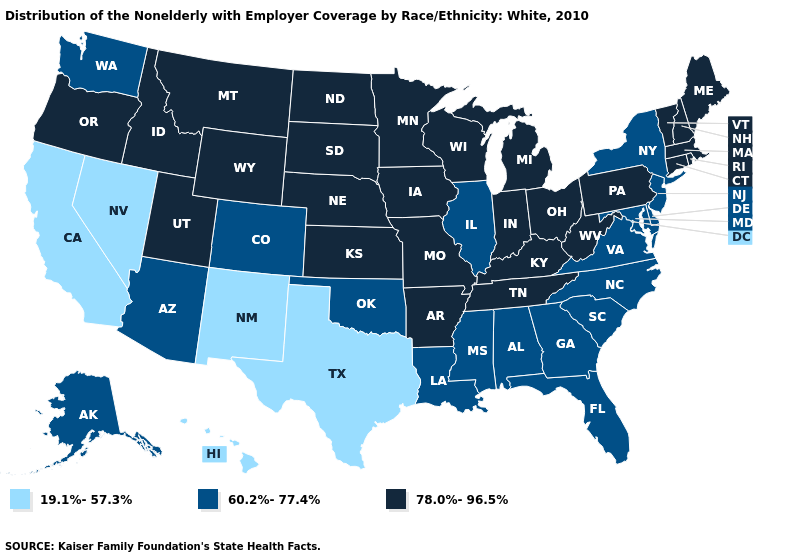Name the states that have a value in the range 78.0%-96.5%?
Short answer required. Arkansas, Connecticut, Idaho, Indiana, Iowa, Kansas, Kentucky, Maine, Massachusetts, Michigan, Minnesota, Missouri, Montana, Nebraska, New Hampshire, North Dakota, Ohio, Oregon, Pennsylvania, Rhode Island, South Dakota, Tennessee, Utah, Vermont, West Virginia, Wisconsin, Wyoming. Name the states that have a value in the range 78.0%-96.5%?
Concise answer only. Arkansas, Connecticut, Idaho, Indiana, Iowa, Kansas, Kentucky, Maine, Massachusetts, Michigan, Minnesota, Missouri, Montana, Nebraska, New Hampshire, North Dakota, Ohio, Oregon, Pennsylvania, Rhode Island, South Dakota, Tennessee, Utah, Vermont, West Virginia, Wisconsin, Wyoming. What is the lowest value in the South?
Keep it brief. 19.1%-57.3%. What is the value of Virginia?
Quick response, please. 60.2%-77.4%. What is the value of Colorado?
Be succinct. 60.2%-77.4%. Does Massachusetts have the lowest value in the Northeast?
Write a very short answer. No. Does Washington have the highest value in the West?
Be succinct. No. What is the value of Washington?
Write a very short answer. 60.2%-77.4%. Name the states that have a value in the range 60.2%-77.4%?
Keep it brief. Alabama, Alaska, Arizona, Colorado, Delaware, Florida, Georgia, Illinois, Louisiana, Maryland, Mississippi, New Jersey, New York, North Carolina, Oklahoma, South Carolina, Virginia, Washington. Among the states that border Nevada , does California have the highest value?
Answer briefly. No. What is the value of Louisiana?
Give a very brief answer. 60.2%-77.4%. What is the value of Maryland?
Write a very short answer. 60.2%-77.4%. Name the states that have a value in the range 60.2%-77.4%?
Be succinct. Alabama, Alaska, Arizona, Colorado, Delaware, Florida, Georgia, Illinois, Louisiana, Maryland, Mississippi, New Jersey, New York, North Carolina, Oklahoma, South Carolina, Virginia, Washington. Does the first symbol in the legend represent the smallest category?
Be succinct. Yes. Does Kansas have the same value as Florida?
Concise answer only. No. 